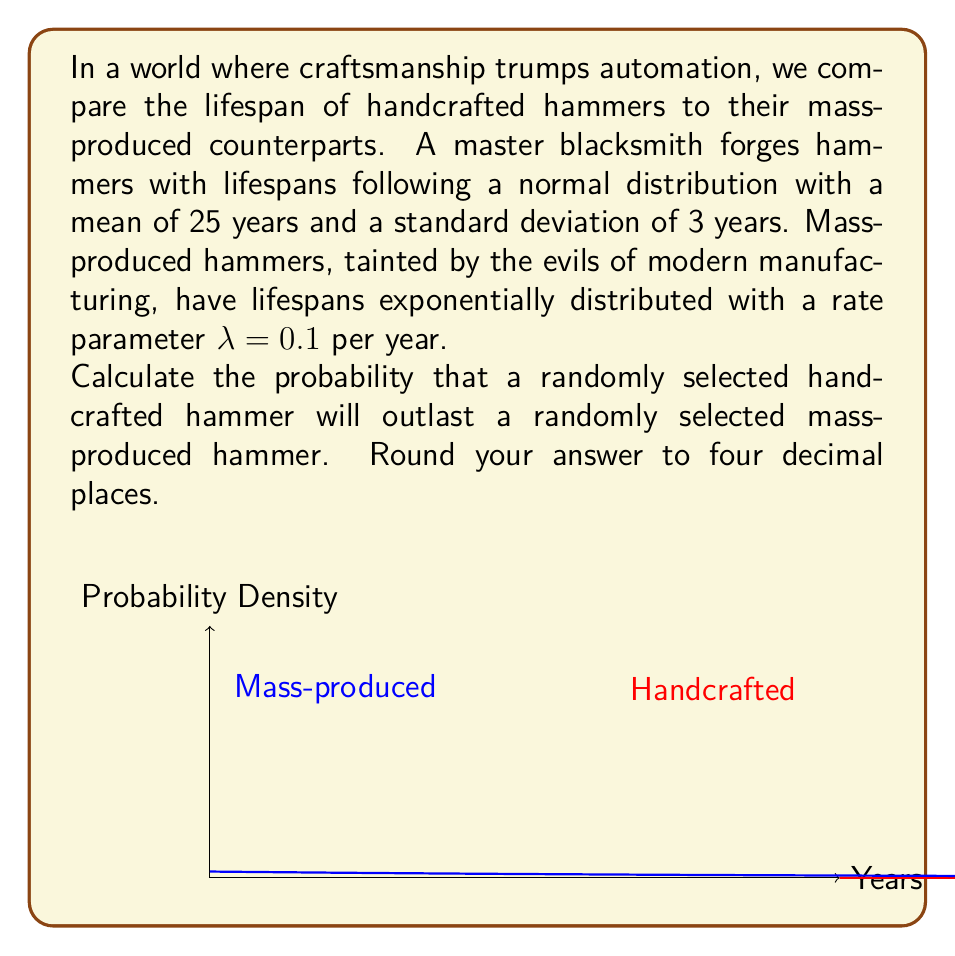Can you solve this math problem? Let's approach this step-by-step:

1) Let X be the lifespan of a handcrafted hammer and Y be the lifespan of a mass-produced hammer.

2) We need to find P(X > Y).

3) We can calculate this using the law of total probability:

   $$P(X > Y) = \int_0^\infty P(X > y) \cdot f_Y(y) dy$$

   where $f_Y(y)$ is the probability density function of Y.

4) For the exponential distribution (mass-produced hammers):
   $$f_Y(y) = \lambda e^{-\lambda y} = 0.1e^{-0.1y}$$

5) For the normal distribution (handcrafted hammers):
   $$P(X > y) = 1 - \Phi(\frac{y - \mu}{\sigma})$$
   where $\Phi$ is the standard normal cumulative distribution function.

6) Substituting these into our integral:

   $$P(X > Y) = \int_0^\infty (1 - \Phi(\frac{y - 25}{3})) \cdot 0.1e^{-0.1y} dy$$

7) This integral doesn't have a closed-form solution, so we need to evaluate it numerically.

8) Using numerical integration techniques (which, reluctantly, we must admit are useful in this case), we find:

   $$P(X > Y) \approx 0.7934$$

9) Rounding to four decimal places: 0.7934
Answer: 0.7934 